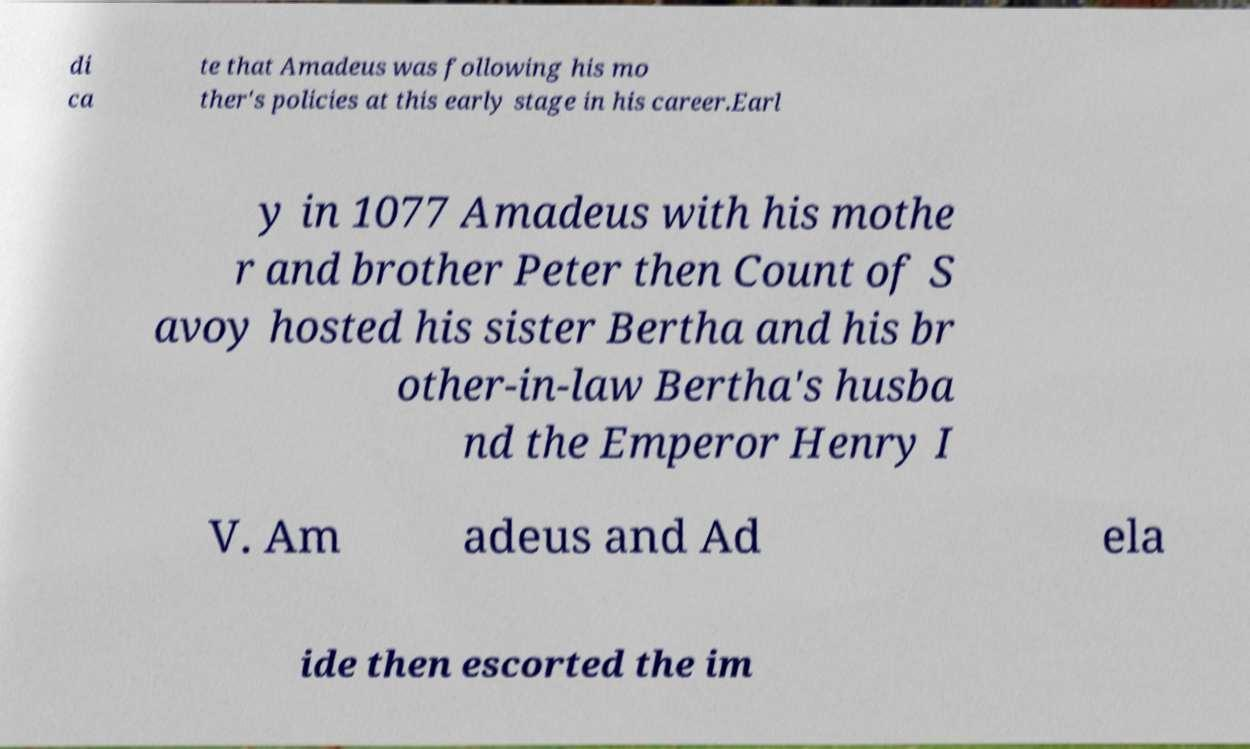Could you assist in decoding the text presented in this image and type it out clearly? di ca te that Amadeus was following his mo ther's policies at this early stage in his career.Earl y in 1077 Amadeus with his mothe r and brother Peter then Count of S avoy hosted his sister Bertha and his br other-in-law Bertha's husba nd the Emperor Henry I V. Am adeus and Ad ela ide then escorted the im 